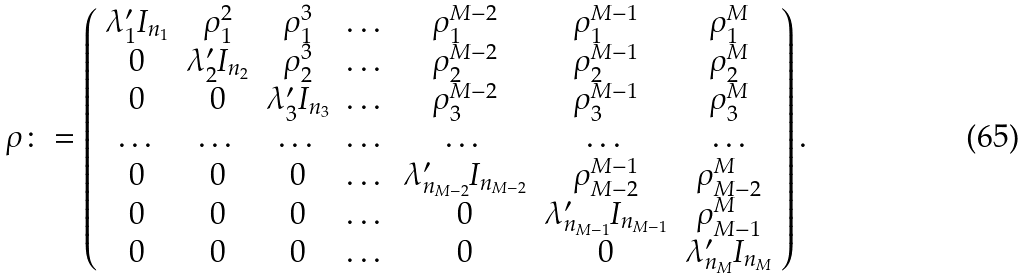<formula> <loc_0><loc_0><loc_500><loc_500>\rho \colon = \left ( \begin{array} { c c c c c c c } \lambda ^ { \prime } _ { 1 } I _ { n _ { 1 } } & \rho _ { 1 } ^ { 2 } & \rho _ { 1 } ^ { 3 } & \dots & \rho _ { 1 } ^ { M - 2 } & \rho _ { 1 } ^ { M - 1 } & \rho _ { 1 } ^ { M } \\ 0 & \lambda ^ { \prime } _ { 2 } I _ { n _ { 2 } } & \rho _ { 2 } ^ { 3 } & \dots & \rho _ { 2 } ^ { M - 2 } & \rho _ { 2 } ^ { M - 1 } & \rho _ { 2 } ^ { M } \\ 0 & 0 & \lambda ^ { \prime } _ { 3 } I _ { n _ { 3 } } & \dots & \rho _ { 3 } ^ { M - 2 } & \rho _ { 3 } ^ { M - 1 } & \rho _ { 3 } ^ { M } \\ \dots & \dots & \dots & \dots & \dots & \dots & \dots \\ 0 & 0 & 0 & \dots & \lambda ^ { \prime } _ { n _ { M - 2 } } I _ { n _ { M - 2 } } & \rho _ { M - 2 } ^ { M - 1 } & \rho _ { M - 2 } ^ { M } \\ 0 & 0 & 0 & \dots & 0 & \lambda ^ { \prime } _ { n _ { M - 1 } } I _ { n _ { M - 1 } } & \rho _ { M - 1 } ^ { M } \\ 0 & 0 & 0 & \dots & 0 & 0 & \lambda ^ { \prime } _ { n _ { M } } I _ { n _ { M } } \end{array} \right ) .</formula> 